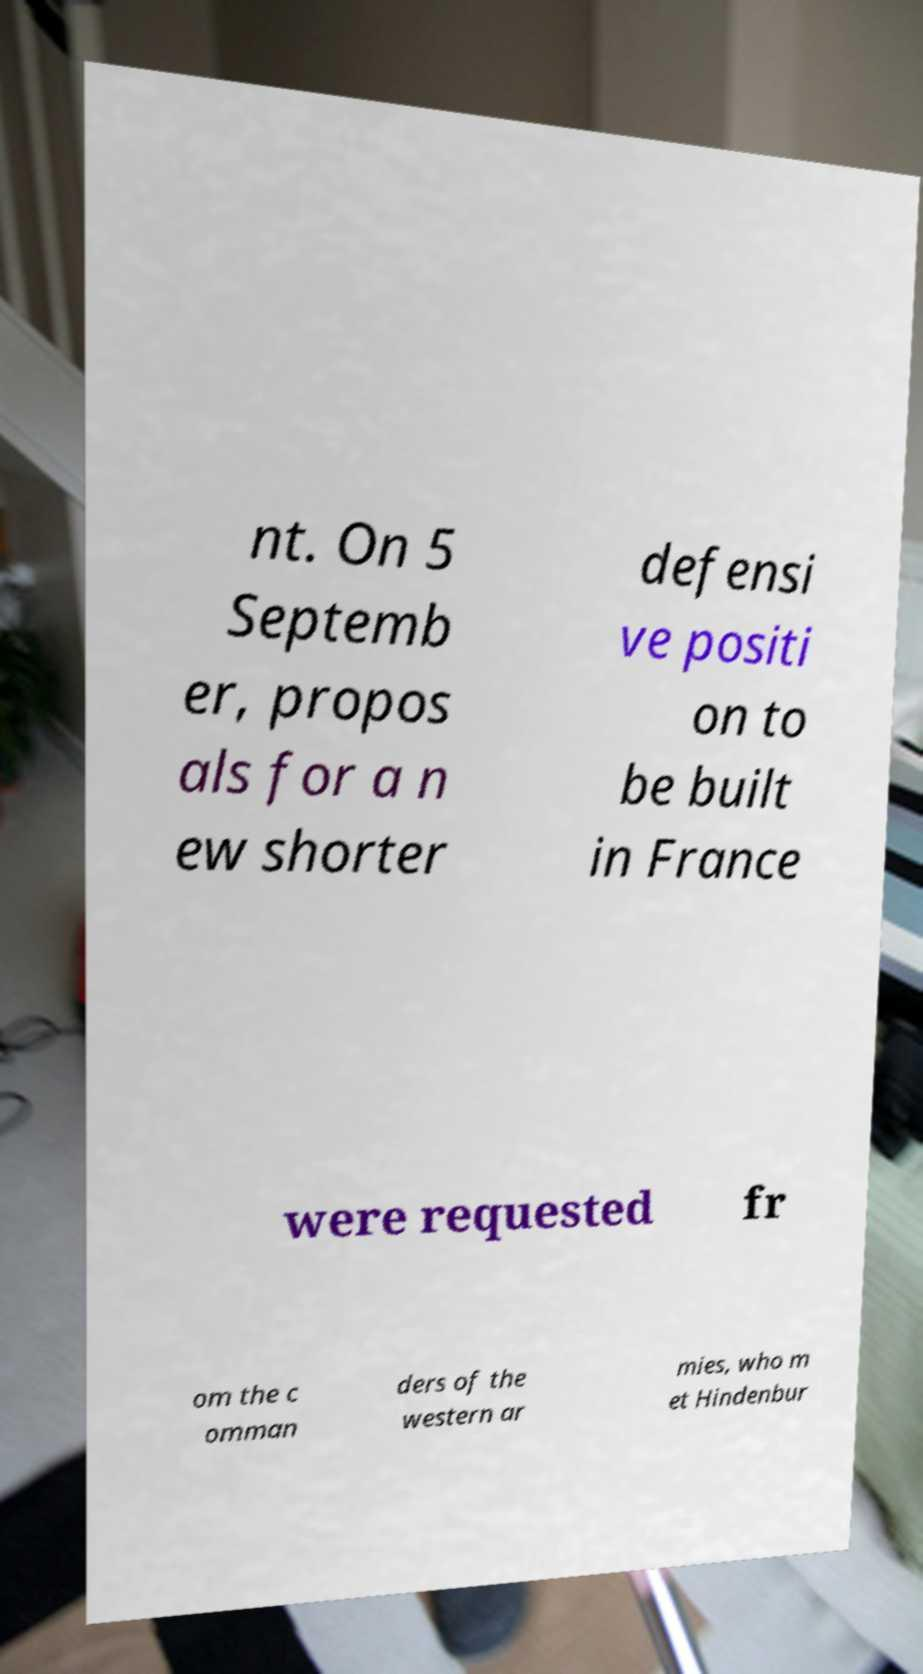Can you accurately transcribe the text from the provided image for me? nt. On 5 Septemb er, propos als for a n ew shorter defensi ve positi on to be built in France were requested fr om the c omman ders of the western ar mies, who m et Hindenbur 